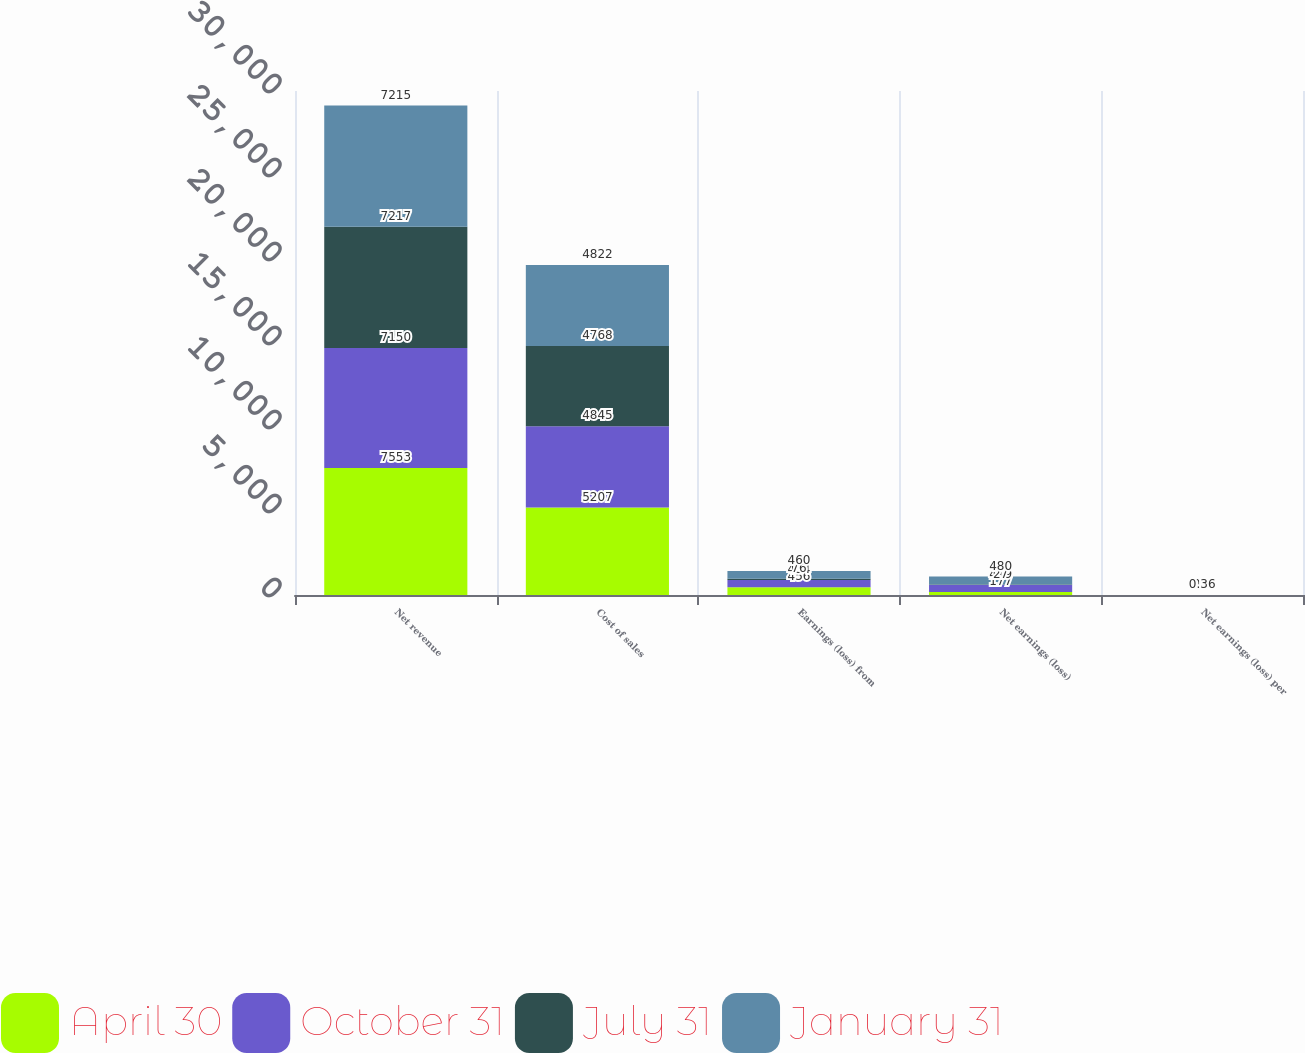Convert chart. <chart><loc_0><loc_0><loc_500><loc_500><stacked_bar_chart><ecel><fcel>Net revenue<fcel>Cost of sales<fcel>Earnings (loss) from<fcel>Net earnings (loss)<fcel>Net earnings (loss) per<nl><fcel>April 30<fcel>7553<fcel>5207<fcel>456<fcel>177<fcel>0.13<nl><fcel>October 31<fcel>7150<fcel>4845<fcel>434<fcel>419<fcel>0.3<nl><fcel>July 31<fcel>7217<fcel>4768<fcel>76<fcel>27<fcel>0.02<nl><fcel>January 31<fcel>7215<fcel>4822<fcel>460<fcel>480<fcel>0.36<nl></chart> 